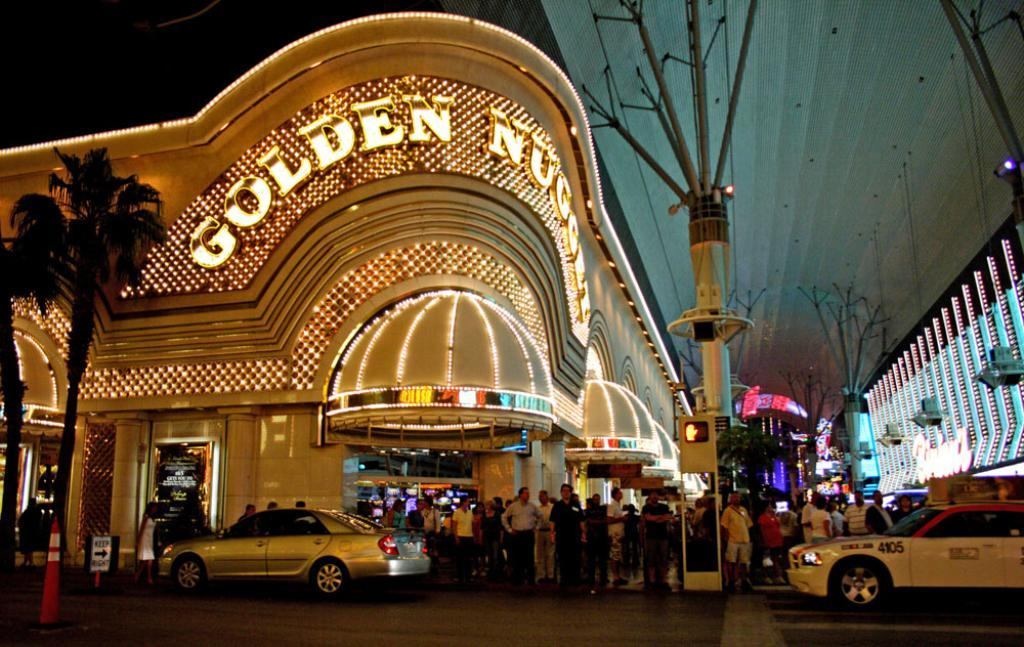<image>
Describe the image concisely. People lining up at a building that says GOLDEN on the top. 